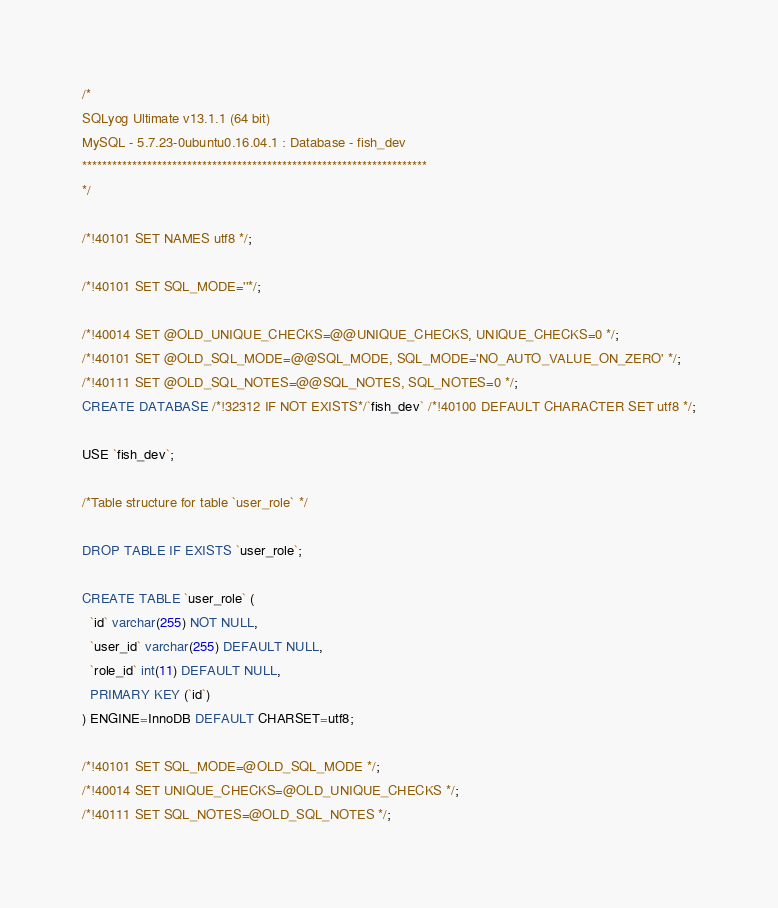Convert code to text. <code><loc_0><loc_0><loc_500><loc_500><_SQL_>/*
SQLyog Ultimate v13.1.1 (64 bit)
MySQL - 5.7.23-0ubuntu0.16.04.1 : Database - fish_dev
*********************************************************************
*/

/*!40101 SET NAMES utf8 */;

/*!40101 SET SQL_MODE=''*/;

/*!40014 SET @OLD_UNIQUE_CHECKS=@@UNIQUE_CHECKS, UNIQUE_CHECKS=0 */;
/*!40101 SET @OLD_SQL_MODE=@@SQL_MODE, SQL_MODE='NO_AUTO_VALUE_ON_ZERO' */;
/*!40111 SET @OLD_SQL_NOTES=@@SQL_NOTES, SQL_NOTES=0 */;
CREATE DATABASE /*!32312 IF NOT EXISTS*/`fish_dev` /*!40100 DEFAULT CHARACTER SET utf8 */;

USE `fish_dev`;

/*Table structure for table `user_role` */

DROP TABLE IF EXISTS `user_role`;

CREATE TABLE `user_role` (
  `id` varchar(255) NOT NULL,
  `user_id` varchar(255) DEFAULT NULL,
  `role_id` int(11) DEFAULT NULL,
  PRIMARY KEY (`id`)
) ENGINE=InnoDB DEFAULT CHARSET=utf8;

/*!40101 SET SQL_MODE=@OLD_SQL_MODE */;
/*!40014 SET UNIQUE_CHECKS=@OLD_UNIQUE_CHECKS */;
/*!40111 SET SQL_NOTES=@OLD_SQL_NOTES */;
</code> 